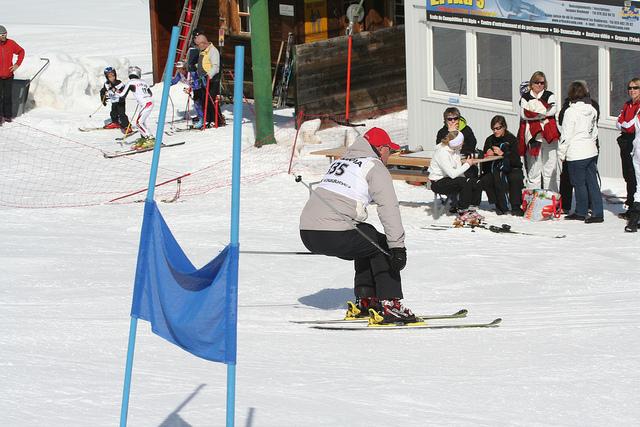Where are the people at?
Keep it brief. Ski slope. Is there snow on the ground?
Give a very brief answer. Yes. What kind of headgear is the subject wearing?
Write a very short answer. Hat. 